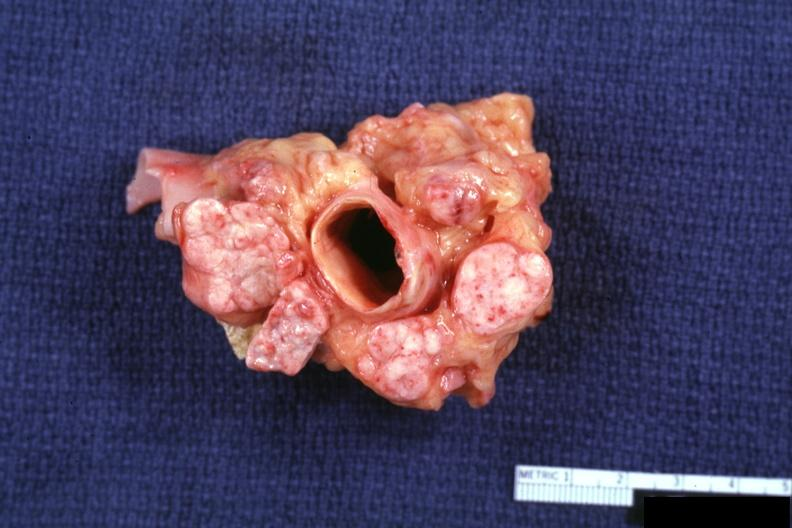how does this image show excellent cross section of aorta and nodes?
Answer the question using a single word or phrase. With obvious tumor in enlarged 